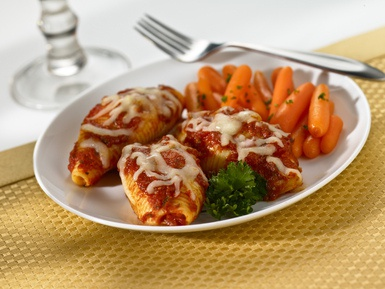Describe the objects in this image and their specific colors. I can see dining table in lightgray, tan, and olive tones, wine glass in lightgray, darkgray, and gray tones, carrot in lightgray, red, maroon, brown, and orange tones, fork in lightgray, darkgray, and gray tones, and broccoli in lightgray, black, darkgreen, and maroon tones in this image. 